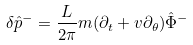<formula> <loc_0><loc_0><loc_500><loc_500>\delta \hat { p } ^ { - } = \frac { L } { 2 \pi } m ( \partial _ { t } + v \partial _ { \theta } ) \hat { \Phi } ^ { - }</formula> 